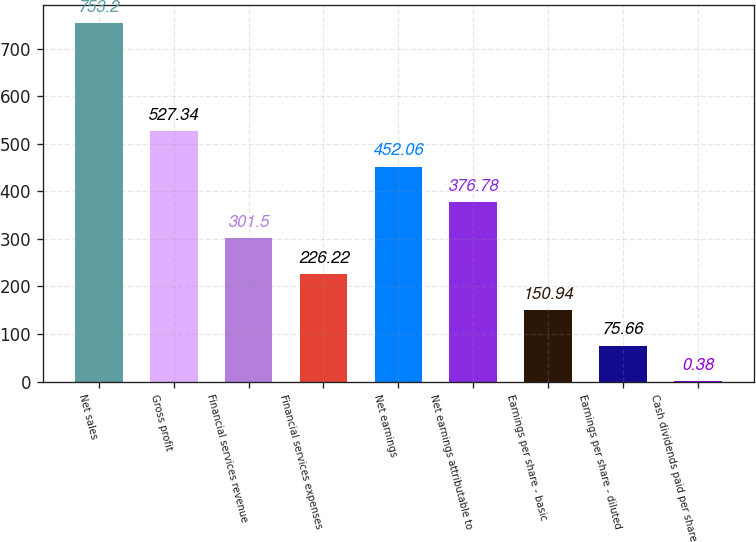<chart> <loc_0><loc_0><loc_500><loc_500><bar_chart><fcel>Net sales<fcel>Gross profit<fcel>Financial services revenue<fcel>Financial services expenses<fcel>Net earnings<fcel>Net earnings attributable to<fcel>Earnings per share - basic<fcel>Earnings per share - diluted<fcel>Cash dividends paid per share<nl><fcel>753.2<fcel>527.34<fcel>301.5<fcel>226.22<fcel>452.06<fcel>376.78<fcel>150.94<fcel>75.66<fcel>0.38<nl></chart> 